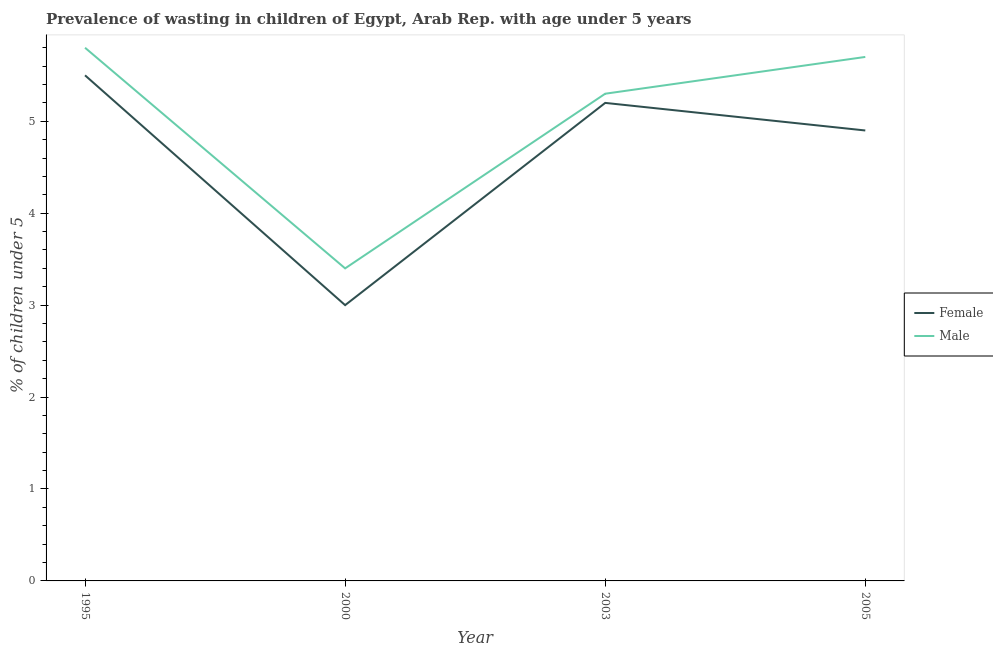Does the line corresponding to percentage of undernourished female children intersect with the line corresponding to percentage of undernourished male children?
Keep it short and to the point. No. What is the percentage of undernourished male children in 1995?
Provide a short and direct response. 5.8. Across all years, what is the maximum percentage of undernourished male children?
Keep it short and to the point. 5.8. Across all years, what is the minimum percentage of undernourished female children?
Give a very brief answer. 3. What is the total percentage of undernourished female children in the graph?
Ensure brevity in your answer.  18.6. What is the difference between the percentage of undernourished male children in 1995 and that in 2005?
Offer a very short reply. 0.1. What is the difference between the percentage of undernourished male children in 2003 and the percentage of undernourished female children in 2000?
Give a very brief answer. 2.3. What is the average percentage of undernourished male children per year?
Offer a very short reply. 5.05. In the year 2003, what is the difference between the percentage of undernourished male children and percentage of undernourished female children?
Your answer should be compact. 0.1. In how many years, is the percentage of undernourished male children greater than 3.4 %?
Your answer should be very brief. 4. What is the ratio of the percentage of undernourished male children in 2003 to that in 2005?
Provide a succinct answer. 0.93. What is the difference between the highest and the second highest percentage of undernourished male children?
Ensure brevity in your answer.  0.1. What is the difference between the highest and the lowest percentage of undernourished male children?
Your answer should be compact. 2.4. Is the percentage of undernourished male children strictly greater than the percentage of undernourished female children over the years?
Give a very brief answer. Yes. How many years are there in the graph?
Your response must be concise. 4. Does the graph contain any zero values?
Your answer should be compact. No. Does the graph contain grids?
Offer a terse response. No. How are the legend labels stacked?
Give a very brief answer. Vertical. What is the title of the graph?
Keep it short and to the point. Prevalence of wasting in children of Egypt, Arab Rep. with age under 5 years. Does "Residents" appear as one of the legend labels in the graph?
Your answer should be very brief. No. What is the label or title of the X-axis?
Provide a succinct answer. Year. What is the label or title of the Y-axis?
Make the answer very short.  % of children under 5. What is the  % of children under 5 of Male in 1995?
Provide a short and direct response. 5.8. What is the  % of children under 5 in Female in 2000?
Your answer should be compact. 3. What is the  % of children under 5 in Male in 2000?
Provide a short and direct response. 3.4. What is the  % of children under 5 in Female in 2003?
Provide a succinct answer. 5.2. What is the  % of children under 5 in Male in 2003?
Keep it short and to the point. 5.3. What is the  % of children under 5 in Female in 2005?
Provide a short and direct response. 4.9. What is the  % of children under 5 in Male in 2005?
Provide a short and direct response. 5.7. Across all years, what is the maximum  % of children under 5 of Male?
Offer a very short reply. 5.8. Across all years, what is the minimum  % of children under 5 of Male?
Provide a short and direct response. 3.4. What is the total  % of children under 5 in Female in the graph?
Give a very brief answer. 18.6. What is the total  % of children under 5 of Male in the graph?
Keep it short and to the point. 20.2. What is the difference between the  % of children under 5 of Male in 1995 and that in 2005?
Keep it short and to the point. 0.1. What is the difference between the  % of children under 5 of Female in 2000 and that in 2003?
Give a very brief answer. -2.2. What is the difference between the  % of children under 5 in Female in 2000 and that in 2005?
Ensure brevity in your answer.  -1.9. What is the difference between the  % of children under 5 of Male in 2000 and that in 2005?
Your answer should be compact. -2.3. What is the difference between the  % of children under 5 in Female in 2003 and that in 2005?
Your answer should be compact. 0.3. What is the difference between the  % of children under 5 of Female in 1995 and the  % of children under 5 of Male in 2003?
Your response must be concise. 0.2. What is the difference between the  % of children under 5 in Female in 1995 and the  % of children under 5 in Male in 2005?
Your response must be concise. -0.2. What is the difference between the  % of children under 5 in Female in 2000 and the  % of children under 5 in Male in 2003?
Your answer should be compact. -2.3. What is the average  % of children under 5 of Female per year?
Offer a terse response. 4.65. What is the average  % of children under 5 in Male per year?
Your answer should be compact. 5.05. In the year 1995, what is the difference between the  % of children under 5 in Female and  % of children under 5 in Male?
Offer a very short reply. -0.3. What is the ratio of the  % of children under 5 of Female in 1995 to that in 2000?
Provide a short and direct response. 1.83. What is the ratio of the  % of children under 5 of Male in 1995 to that in 2000?
Offer a terse response. 1.71. What is the ratio of the  % of children under 5 of Female in 1995 to that in 2003?
Offer a terse response. 1.06. What is the ratio of the  % of children under 5 in Male in 1995 to that in 2003?
Ensure brevity in your answer.  1.09. What is the ratio of the  % of children under 5 in Female in 1995 to that in 2005?
Make the answer very short. 1.12. What is the ratio of the  % of children under 5 in Male in 1995 to that in 2005?
Provide a short and direct response. 1.02. What is the ratio of the  % of children under 5 in Female in 2000 to that in 2003?
Provide a succinct answer. 0.58. What is the ratio of the  % of children under 5 in Male in 2000 to that in 2003?
Provide a short and direct response. 0.64. What is the ratio of the  % of children under 5 in Female in 2000 to that in 2005?
Provide a succinct answer. 0.61. What is the ratio of the  % of children under 5 in Male in 2000 to that in 2005?
Your response must be concise. 0.6. What is the ratio of the  % of children under 5 of Female in 2003 to that in 2005?
Offer a very short reply. 1.06. What is the ratio of the  % of children under 5 in Male in 2003 to that in 2005?
Offer a very short reply. 0.93. What is the difference between the highest and the second highest  % of children under 5 of Female?
Provide a succinct answer. 0.3. What is the difference between the highest and the second highest  % of children under 5 of Male?
Your answer should be very brief. 0.1. What is the difference between the highest and the lowest  % of children under 5 in Female?
Your answer should be very brief. 2.5. 